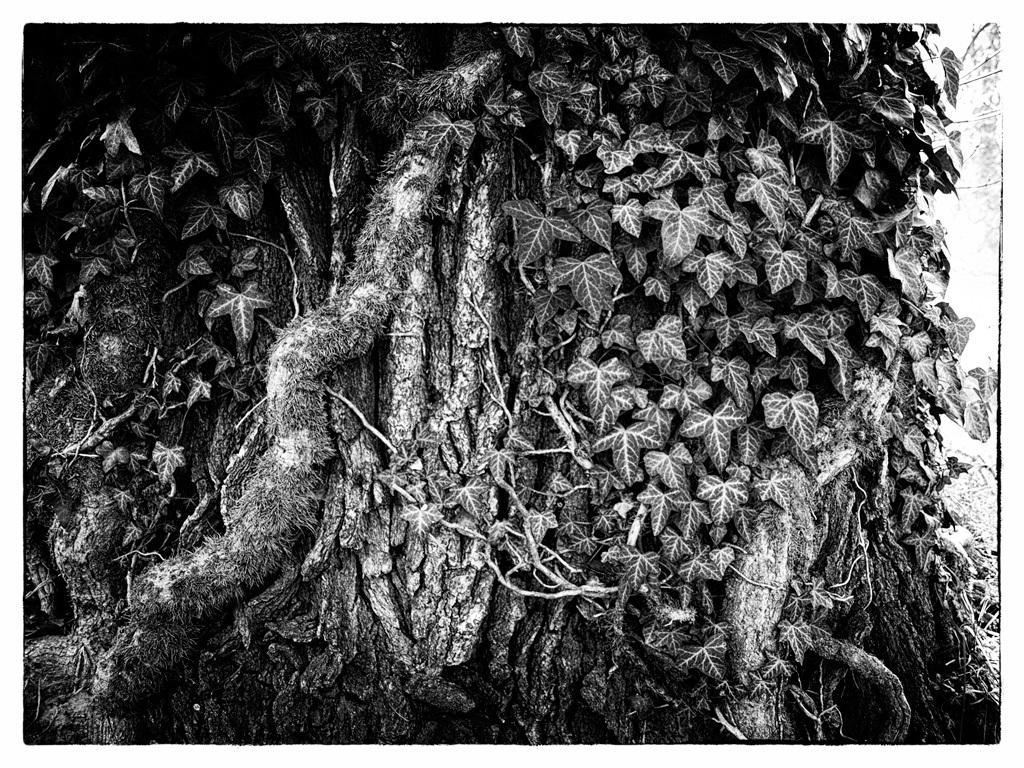Describe this image in one or two sentences. In this image we can see a bark of the tree with some leaves. 